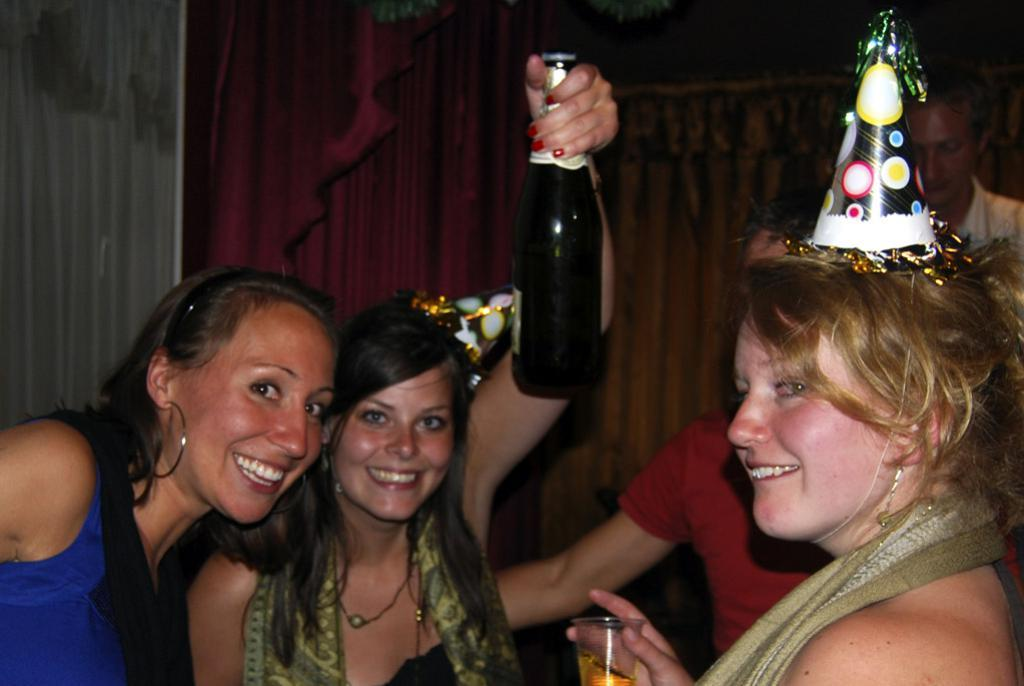How many people are present in the image? There are four people in the image. What is one person holding in the image? One person is holding a bottle. What is another person holding in the image? Another person is holding a glass. Is the person holding the bottle aiming a rifle at the person holding the glass? There is no rifle present in the image, and the person holding the bottle is not aiming any weapon at the person holding the glass. 